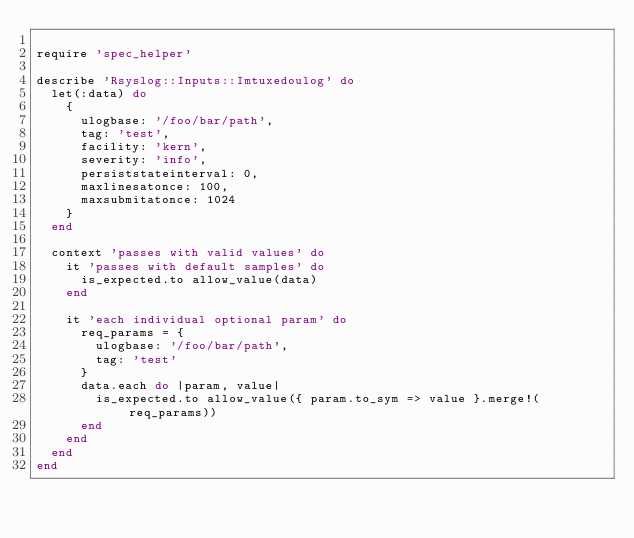Convert code to text. <code><loc_0><loc_0><loc_500><loc_500><_Ruby_>
require 'spec_helper'

describe 'Rsyslog::Inputs::Imtuxedoulog' do
  let(:data) do
    {
      ulogbase: '/foo/bar/path',
      tag: 'test',
      facility: 'kern',
      severity: 'info',
      persiststateinterval: 0,
      maxlinesatonce: 100,
      maxsubmitatonce: 1024
    }
  end

  context 'passes with valid values' do
    it 'passes with default samples' do
      is_expected.to allow_value(data)
    end

    it 'each individual optional param' do
      req_params = {
        ulogbase: '/foo/bar/path',
        tag: 'test'
      }
      data.each do |param, value|
        is_expected.to allow_value({ param.to_sym => value }.merge!(req_params))
      end
    end
  end
end
</code> 